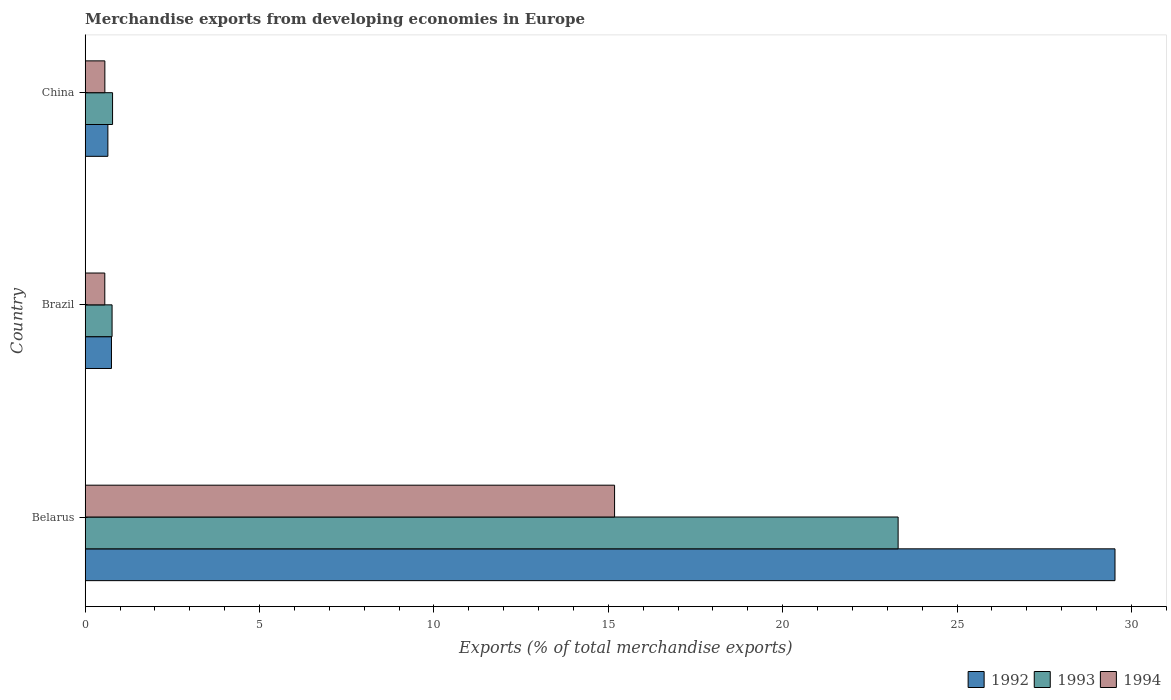How many different coloured bars are there?
Your response must be concise. 3. How many groups of bars are there?
Your response must be concise. 3. In how many cases, is the number of bars for a given country not equal to the number of legend labels?
Provide a succinct answer. 0. What is the percentage of total merchandise exports in 1992 in Belarus?
Provide a short and direct response. 29.53. Across all countries, what is the maximum percentage of total merchandise exports in 1993?
Ensure brevity in your answer.  23.31. Across all countries, what is the minimum percentage of total merchandise exports in 1992?
Make the answer very short. 0.65. In which country was the percentage of total merchandise exports in 1993 maximum?
Your answer should be very brief. Belarus. In which country was the percentage of total merchandise exports in 1994 minimum?
Your response must be concise. Brazil. What is the total percentage of total merchandise exports in 1992 in the graph?
Keep it short and to the point. 30.93. What is the difference between the percentage of total merchandise exports in 1993 in Brazil and that in China?
Provide a succinct answer. -0.01. What is the difference between the percentage of total merchandise exports in 1994 in Belarus and the percentage of total merchandise exports in 1993 in Brazil?
Give a very brief answer. 14.41. What is the average percentage of total merchandise exports in 1994 per country?
Give a very brief answer. 5.43. What is the difference between the percentage of total merchandise exports in 1992 and percentage of total merchandise exports in 1993 in China?
Provide a short and direct response. -0.13. In how many countries, is the percentage of total merchandise exports in 1993 greater than 17 %?
Your answer should be compact. 1. What is the ratio of the percentage of total merchandise exports in 1993 in Belarus to that in China?
Keep it short and to the point. 29.71. What is the difference between the highest and the second highest percentage of total merchandise exports in 1994?
Offer a very short reply. 14.62. What is the difference between the highest and the lowest percentage of total merchandise exports in 1993?
Provide a succinct answer. 22.54. What does the 2nd bar from the top in China represents?
Offer a terse response. 1993. What does the 3rd bar from the bottom in China represents?
Offer a very short reply. 1994. How many bars are there?
Offer a very short reply. 9. Are all the bars in the graph horizontal?
Your answer should be compact. Yes. Are the values on the major ticks of X-axis written in scientific E-notation?
Your answer should be compact. No. Does the graph contain any zero values?
Provide a succinct answer. No. Does the graph contain grids?
Offer a very short reply. No. Where does the legend appear in the graph?
Your answer should be compact. Bottom right. What is the title of the graph?
Ensure brevity in your answer.  Merchandise exports from developing economies in Europe. Does "1961" appear as one of the legend labels in the graph?
Make the answer very short. No. What is the label or title of the X-axis?
Offer a very short reply. Exports (% of total merchandise exports). What is the Exports (% of total merchandise exports) of 1992 in Belarus?
Your response must be concise. 29.53. What is the Exports (% of total merchandise exports) of 1993 in Belarus?
Ensure brevity in your answer.  23.31. What is the Exports (% of total merchandise exports) of 1994 in Belarus?
Offer a very short reply. 15.18. What is the Exports (% of total merchandise exports) in 1992 in Brazil?
Make the answer very short. 0.75. What is the Exports (% of total merchandise exports) in 1993 in Brazil?
Provide a short and direct response. 0.77. What is the Exports (% of total merchandise exports) of 1994 in Brazil?
Keep it short and to the point. 0.56. What is the Exports (% of total merchandise exports) in 1992 in China?
Give a very brief answer. 0.65. What is the Exports (% of total merchandise exports) of 1993 in China?
Provide a succinct answer. 0.78. What is the Exports (% of total merchandise exports) of 1994 in China?
Your response must be concise. 0.56. Across all countries, what is the maximum Exports (% of total merchandise exports) in 1992?
Ensure brevity in your answer.  29.53. Across all countries, what is the maximum Exports (% of total merchandise exports) in 1993?
Your response must be concise. 23.31. Across all countries, what is the maximum Exports (% of total merchandise exports) in 1994?
Make the answer very short. 15.18. Across all countries, what is the minimum Exports (% of total merchandise exports) in 1992?
Ensure brevity in your answer.  0.65. Across all countries, what is the minimum Exports (% of total merchandise exports) in 1993?
Provide a succinct answer. 0.77. Across all countries, what is the minimum Exports (% of total merchandise exports) in 1994?
Offer a terse response. 0.56. What is the total Exports (% of total merchandise exports) of 1992 in the graph?
Your answer should be very brief. 30.93. What is the total Exports (% of total merchandise exports) in 1993 in the graph?
Keep it short and to the point. 24.86. What is the total Exports (% of total merchandise exports) of 1994 in the graph?
Your answer should be compact. 16.3. What is the difference between the Exports (% of total merchandise exports) of 1992 in Belarus and that in Brazil?
Make the answer very short. 28.77. What is the difference between the Exports (% of total merchandise exports) in 1993 in Belarus and that in Brazil?
Your answer should be very brief. 22.54. What is the difference between the Exports (% of total merchandise exports) of 1994 in Belarus and that in Brazil?
Make the answer very short. 14.62. What is the difference between the Exports (% of total merchandise exports) in 1992 in Belarus and that in China?
Keep it short and to the point. 28.88. What is the difference between the Exports (% of total merchandise exports) of 1993 in Belarus and that in China?
Keep it short and to the point. 22.52. What is the difference between the Exports (% of total merchandise exports) in 1994 in Belarus and that in China?
Your answer should be compact. 14.62. What is the difference between the Exports (% of total merchandise exports) of 1992 in Brazil and that in China?
Ensure brevity in your answer.  0.1. What is the difference between the Exports (% of total merchandise exports) in 1993 in Brazil and that in China?
Your answer should be compact. -0.01. What is the difference between the Exports (% of total merchandise exports) in 1994 in Brazil and that in China?
Give a very brief answer. -0. What is the difference between the Exports (% of total merchandise exports) of 1992 in Belarus and the Exports (% of total merchandise exports) of 1993 in Brazil?
Your response must be concise. 28.76. What is the difference between the Exports (% of total merchandise exports) of 1992 in Belarus and the Exports (% of total merchandise exports) of 1994 in Brazil?
Provide a short and direct response. 28.97. What is the difference between the Exports (% of total merchandise exports) of 1993 in Belarus and the Exports (% of total merchandise exports) of 1994 in Brazil?
Provide a succinct answer. 22.75. What is the difference between the Exports (% of total merchandise exports) in 1992 in Belarus and the Exports (% of total merchandise exports) in 1993 in China?
Your answer should be compact. 28.74. What is the difference between the Exports (% of total merchandise exports) in 1992 in Belarus and the Exports (% of total merchandise exports) in 1994 in China?
Your answer should be compact. 28.96. What is the difference between the Exports (% of total merchandise exports) in 1993 in Belarus and the Exports (% of total merchandise exports) in 1994 in China?
Your answer should be compact. 22.75. What is the difference between the Exports (% of total merchandise exports) in 1992 in Brazil and the Exports (% of total merchandise exports) in 1993 in China?
Your answer should be very brief. -0.03. What is the difference between the Exports (% of total merchandise exports) of 1992 in Brazil and the Exports (% of total merchandise exports) of 1994 in China?
Offer a terse response. 0.19. What is the difference between the Exports (% of total merchandise exports) in 1993 in Brazil and the Exports (% of total merchandise exports) in 1994 in China?
Offer a terse response. 0.21. What is the average Exports (% of total merchandise exports) of 1992 per country?
Keep it short and to the point. 10.31. What is the average Exports (% of total merchandise exports) of 1993 per country?
Offer a very short reply. 8.29. What is the average Exports (% of total merchandise exports) in 1994 per country?
Give a very brief answer. 5.43. What is the difference between the Exports (% of total merchandise exports) of 1992 and Exports (% of total merchandise exports) of 1993 in Belarus?
Your answer should be compact. 6.22. What is the difference between the Exports (% of total merchandise exports) in 1992 and Exports (% of total merchandise exports) in 1994 in Belarus?
Your answer should be compact. 14.35. What is the difference between the Exports (% of total merchandise exports) of 1993 and Exports (% of total merchandise exports) of 1994 in Belarus?
Provide a succinct answer. 8.13. What is the difference between the Exports (% of total merchandise exports) of 1992 and Exports (% of total merchandise exports) of 1993 in Brazil?
Ensure brevity in your answer.  -0.02. What is the difference between the Exports (% of total merchandise exports) of 1992 and Exports (% of total merchandise exports) of 1994 in Brazil?
Your response must be concise. 0.19. What is the difference between the Exports (% of total merchandise exports) of 1993 and Exports (% of total merchandise exports) of 1994 in Brazil?
Your answer should be compact. 0.21. What is the difference between the Exports (% of total merchandise exports) of 1992 and Exports (% of total merchandise exports) of 1993 in China?
Your response must be concise. -0.13. What is the difference between the Exports (% of total merchandise exports) in 1992 and Exports (% of total merchandise exports) in 1994 in China?
Offer a terse response. 0.09. What is the difference between the Exports (% of total merchandise exports) of 1993 and Exports (% of total merchandise exports) of 1994 in China?
Offer a very short reply. 0.22. What is the ratio of the Exports (% of total merchandise exports) of 1992 in Belarus to that in Brazil?
Your answer should be very brief. 39.22. What is the ratio of the Exports (% of total merchandise exports) in 1993 in Belarus to that in Brazil?
Provide a succinct answer. 30.26. What is the ratio of the Exports (% of total merchandise exports) in 1994 in Belarus to that in Brazil?
Offer a very short reply. 27.03. What is the ratio of the Exports (% of total merchandise exports) of 1992 in Belarus to that in China?
Provide a succinct answer. 45.45. What is the ratio of the Exports (% of total merchandise exports) of 1993 in Belarus to that in China?
Provide a succinct answer. 29.71. What is the ratio of the Exports (% of total merchandise exports) of 1994 in Belarus to that in China?
Your answer should be compact. 26.95. What is the ratio of the Exports (% of total merchandise exports) of 1992 in Brazil to that in China?
Give a very brief answer. 1.16. What is the ratio of the Exports (% of total merchandise exports) in 1993 in Brazil to that in China?
Give a very brief answer. 0.98. What is the ratio of the Exports (% of total merchandise exports) in 1994 in Brazil to that in China?
Make the answer very short. 1. What is the difference between the highest and the second highest Exports (% of total merchandise exports) of 1992?
Your answer should be very brief. 28.77. What is the difference between the highest and the second highest Exports (% of total merchandise exports) of 1993?
Give a very brief answer. 22.52. What is the difference between the highest and the second highest Exports (% of total merchandise exports) of 1994?
Your answer should be very brief. 14.62. What is the difference between the highest and the lowest Exports (% of total merchandise exports) in 1992?
Give a very brief answer. 28.88. What is the difference between the highest and the lowest Exports (% of total merchandise exports) in 1993?
Ensure brevity in your answer.  22.54. What is the difference between the highest and the lowest Exports (% of total merchandise exports) in 1994?
Make the answer very short. 14.62. 